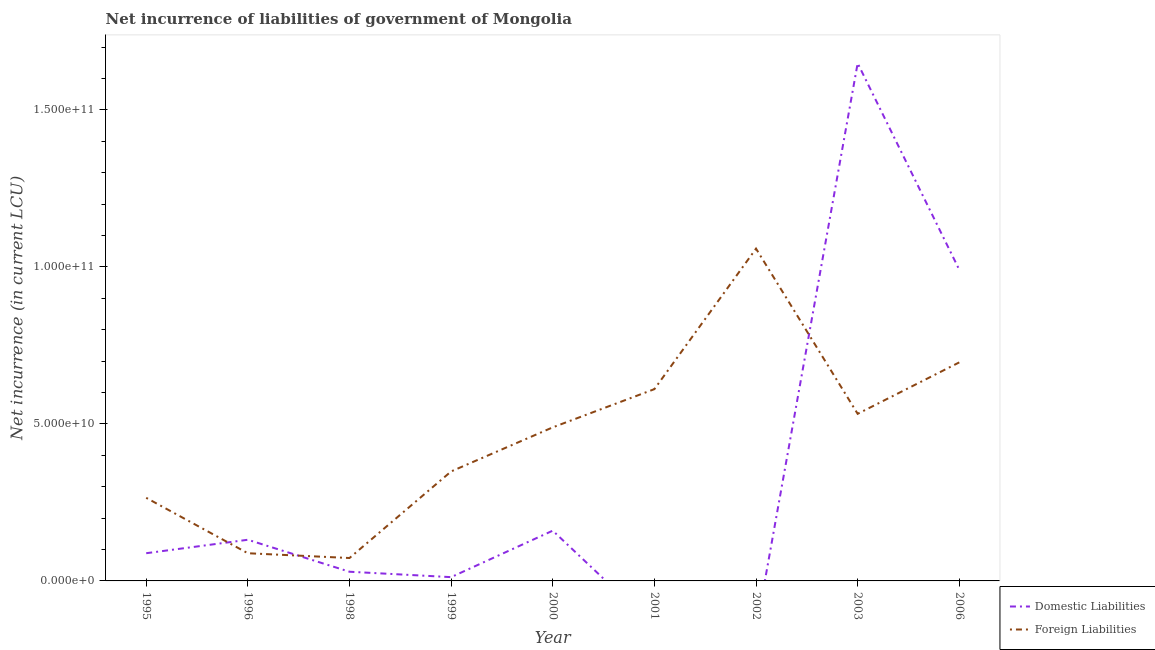How many different coloured lines are there?
Offer a very short reply. 2. Does the line corresponding to net incurrence of domestic liabilities intersect with the line corresponding to net incurrence of foreign liabilities?
Make the answer very short. Yes. What is the net incurrence of domestic liabilities in 2003?
Ensure brevity in your answer.  1.65e+11. Across all years, what is the maximum net incurrence of domestic liabilities?
Ensure brevity in your answer.  1.65e+11. Across all years, what is the minimum net incurrence of foreign liabilities?
Give a very brief answer. 7.29e+09. What is the total net incurrence of foreign liabilities in the graph?
Your answer should be very brief. 4.16e+11. What is the difference between the net incurrence of domestic liabilities in 1998 and that in 1999?
Make the answer very short. 1.72e+09. What is the difference between the net incurrence of foreign liabilities in 1996 and the net incurrence of domestic liabilities in 1998?
Your answer should be very brief. 5.89e+09. What is the average net incurrence of foreign liabilities per year?
Make the answer very short. 4.62e+1. In the year 2006, what is the difference between the net incurrence of foreign liabilities and net incurrence of domestic liabilities?
Your response must be concise. -2.95e+1. What is the ratio of the net incurrence of foreign liabilities in 2000 to that in 2002?
Your answer should be very brief. 0.46. Is the net incurrence of domestic liabilities in 1999 less than that in 2000?
Keep it short and to the point. Yes. What is the difference between the highest and the second highest net incurrence of foreign liabilities?
Make the answer very short. 3.62e+1. What is the difference between the highest and the lowest net incurrence of domestic liabilities?
Provide a succinct answer. 1.65e+11. Is the sum of the net incurrence of foreign liabilities in 2000 and 2002 greater than the maximum net incurrence of domestic liabilities across all years?
Make the answer very short. No. Does the net incurrence of domestic liabilities monotonically increase over the years?
Your response must be concise. No. Is the net incurrence of foreign liabilities strictly less than the net incurrence of domestic liabilities over the years?
Your response must be concise. No. How many lines are there?
Ensure brevity in your answer.  2. How many years are there in the graph?
Give a very brief answer. 9. Are the values on the major ticks of Y-axis written in scientific E-notation?
Provide a short and direct response. Yes. Does the graph contain grids?
Offer a terse response. No. How are the legend labels stacked?
Provide a succinct answer. Vertical. What is the title of the graph?
Keep it short and to the point. Net incurrence of liabilities of government of Mongolia. Does "Foreign Liabilities" appear as one of the legend labels in the graph?
Offer a terse response. Yes. What is the label or title of the Y-axis?
Keep it short and to the point. Net incurrence (in current LCU). What is the Net incurrence (in current LCU) in Domestic Liabilities in 1995?
Provide a short and direct response. 8.83e+09. What is the Net incurrence (in current LCU) of Foreign Liabilities in 1995?
Your answer should be very brief. 2.65e+1. What is the Net incurrence (in current LCU) in Domestic Liabilities in 1996?
Make the answer very short. 1.31e+1. What is the Net incurrence (in current LCU) of Foreign Liabilities in 1996?
Keep it short and to the point. 8.82e+09. What is the Net incurrence (in current LCU) of Domestic Liabilities in 1998?
Keep it short and to the point. 2.93e+09. What is the Net incurrence (in current LCU) of Foreign Liabilities in 1998?
Offer a terse response. 7.29e+09. What is the Net incurrence (in current LCU) in Domestic Liabilities in 1999?
Provide a short and direct response. 1.20e+09. What is the Net incurrence (in current LCU) in Foreign Liabilities in 1999?
Offer a terse response. 3.49e+1. What is the Net incurrence (in current LCU) of Domestic Liabilities in 2000?
Keep it short and to the point. 1.60e+1. What is the Net incurrence (in current LCU) of Foreign Liabilities in 2000?
Your answer should be very brief. 4.89e+1. What is the Net incurrence (in current LCU) in Domestic Liabilities in 2001?
Offer a very short reply. 0. What is the Net incurrence (in current LCU) in Foreign Liabilities in 2001?
Your response must be concise. 6.11e+1. What is the Net incurrence (in current LCU) of Domestic Liabilities in 2002?
Give a very brief answer. 0. What is the Net incurrence (in current LCU) in Foreign Liabilities in 2002?
Offer a very short reply. 1.06e+11. What is the Net incurrence (in current LCU) of Domestic Liabilities in 2003?
Make the answer very short. 1.65e+11. What is the Net incurrence (in current LCU) of Foreign Liabilities in 2003?
Give a very brief answer. 5.32e+1. What is the Net incurrence (in current LCU) of Domestic Liabilities in 2006?
Offer a terse response. 9.91e+1. What is the Net incurrence (in current LCU) in Foreign Liabilities in 2006?
Your answer should be very brief. 6.96e+1. Across all years, what is the maximum Net incurrence (in current LCU) of Domestic Liabilities?
Your answer should be very brief. 1.65e+11. Across all years, what is the maximum Net incurrence (in current LCU) of Foreign Liabilities?
Give a very brief answer. 1.06e+11. Across all years, what is the minimum Net incurrence (in current LCU) in Domestic Liabilities?
Make the answer very short. 0. Across all years, what is the minimum Net incurrence (in current LCU) of Foreign Liabilities?
Make the answer very short. 7.29e+09. What is the total Net incurrence (in current LCU) of Domestic Liabilities in the graph?
Offer a very short reply. 3.06e+11. What is the total Net incurrence (in current LCU) of Foreign Liabilities in the graph?
Ensure brevity in your answer.  4.16e+11. What is the difference between the Net incurrence (in current LCU) in Domestic Liabilities in 1995 and that in 1996?
Ensure brevity in your answer.  -4.28e+09. What is the difference between the Net incurrence (in current LCU) in Foreign Liabilities in 1995 and that in 1996?
Offer a very short reply. 1.77e+1. What is the difference between the Net incurrence (in current LCU) of Domestic Liabilities in 1995 and that in 1998?
Your answer should be very brief. 5.90e+09. What is the difference between the Net incurrence (in current LCU) in Foreign Liabilities in 1995 and that in 1998?
Offer a terse response. 1.92e+1. What is the difference between the Net incurrence (in current LCU) in Domestic Liabilities in 1995 and that in 1999?
Make the answer very short. 7.62e+09. What is the difference between the Net incurrence (in current LCU) of Foreign Liabilities in 1995 and that in 1999?
Offer a very short reply. -8.40e+09. What is the difference between the Net incurrence (in current LCU) of Domestic Liabilities in 1995 and that in 2000?
Offer a very short reply. -7.18e+09. What is the difference between the Net incurrence (in current LCU) in Foreign Liabilities in 1995 and that in 2000?
Provide a short and direct response. -2.24e+1. What is the difference between the Net incurrence (in current LCU) in Foreign Liabilities in 1995 and that in 2001?
Your answer should be very brief. -3.46e+1. What is the difference between the Net incurrence (in current LCU) in Foreign Liabilities in 1995 and that in 2002?
Give a very brief answer. -7.94e+1. What is the difference between the Net incurrence (in current LCU) in Domestic Liabilities in 1995 and that in 2003?
Make the answer very short. -1.56e+11. What is the difference between the Net incurrence (in current LCU) in Foreign Liabilities in 1995 and that in 2003?
Keep it short and to the point. -2.68e+1. What is the difference between the Net incurrence (in current LCU) of Domestic Liabilities in 1995 and that in 2006?
Provide a succinct answer. -9.03e+1. What is the difference between the Net incurrence (in current LCU) in Foreign Liabilities in 1995 and that in 2006?
Provide a succinct answer. -4.31e+1. What is the difference between the Net incurrence (in current LCU) of Domestic Liabilities in 1996 and that in 1998?
Give a very brief answer. 1.02e+1. What is the difference between the Net incurrence (in current LCU) in Foreign Liabilities in 1996 and that in 1998?
Offer a very short reply. 1.52e+09. What is the difference between the Net incurrence (in current LCU) of Domestic Liabilities in 1996 and that in 1999?
Ensure brevity in your answer.  1.19e+1. What is the difference between the Net incurrence (in current LCU) in Foreign Liabilities in 1996 and that in 1999?
Your response must be concise. -2.61e+1. What is the difference between the Net incurrence (in current LCU) of Domestic Liabilities in 1996 and that in 2000?
Keep it short and to the point. -2.90e+09. What is the difference between the Net incurrence (in current LCU) of Foreign Liabilities in 1996 and that in 2000?
Provide a short and direct response. -4.01e+1. What is the difference between the Net incurrence (in current LCU) of Foreign Liabilities in 1996 and that in 2001?
Keep it short and to the point. -5.23e+1. What is the difference between the Net incurrence (in current LCU) in Foreign Liabilities in 1996 and that in 2002?
Give a very brief answer. -9.70e+1. What is the difference between the Net incurrence (in current LCU) in Domestic Liabilities in 1996 and that in 2003?
Provide a succinct answer. -1.52e+11. What is the difference between the Net incurrence (in current LCU) in Foreign Liabilities in 1996 and that in 2003?
Your answer should be compact. -4.44e+1. What is the difference between the Net incurrence (in current LCU) of Domestic Liabilities in 1996 and that in 2006?
Give a very brief answer. -8.60e+1. What is the difference between the Net incurrence (in current LCU) in Foreign Liabilities in 1996 and that in 2006?
Keep it short and to the point. -6.08e+1. What is the difference between the Net incurrence (in current LCU) in Domestic Liabilities in 1998 and that in 1999?
Your response must be concise. 1.72e+09. What is the difference between the Net incurrence (in current LCU) of Foreign Liabilities in 1998 and that in 1999?
Ensure brevity in your answer.  -2.76e+1. What is the difference between the Net incurrence (in current LCU) of Domestic Liabilities in 1998 and that in 2000?
Provide a succinct answer. -1.31e+1. What is the difference between the Net incurrence (in current LCU) of Foreign Liabilities in 1998 and that in 2000?
Provide a short and direct response. -4.16e+1. What is the difference between the Net incurrence (in current LCU) of Foreign Liabilities in 1998 and that in 2001?
Your answer should be very brief. -5.38e+1. What is the difference between the Net incurrence (in current LCU) of Foreign Liabilities in 1998 and that in 2002?
Keep it short and to the point. -9.85e+1. What is the difference between the Net incurrence (in current LCU) in Domestic Liabilities in 1998 and that in 2003?
Provide a short and direct response. -1.62e+11. What is the difference between the Net incurrence (in current LCU) in Foreign Liabilities in 1998 and that in 2003?
Your answer should be compact. -4.59e+1. What is the difference between the Net incurrence (in current LCU) in Domestic Liabilities in 1998 and that in 2006?
Give a very brief answer. -9.62e+1. What is the difference between the Net incurrence (in current LCU) of Foreign Liabilities in 1998 and that in 2006?
Your answer should be very brief. -6.23e+1. What is the difference between the Net incurrence (in current LCU) of Domestic Liabilities in 1999 and that in 2000?
Provide a succinct answer. -1.48e+1. What is the difference between the Net incurrence (in current LCU) in Foreign Liabilities in 1999 and that in 2000?
Provide a succinct answer. -1.40e+1. What is the difference between the Net incurrence (in current LCU) of Foreign Liabilities in 1999 and that in 2001?
Make the answer very short. -2.62e+1. What is the difference between the Net incurrence (in current LCU) in Foreign Liabilities in 1999 and that in 2002?
Provide a succinct answer. -7.10e+1. What is the difference between the Net incurrence (in current LCU) of Domestic Liabilities in 1999 and that in 2003?
Your answer should be very brief. -1.64e+11. What is the difference between the Net incurrence (in current LCU) in Foreign Liabilities in 1999 and that in 2003?
Provide a succinct answer. -1.83e+1. What is the difference between the Net incurrence (in current LCU) of Domestic Liabilities in 1999 and that in 2006?
Give a very brief answer. -9.79e+1. What is the difference between the Net incurrence (in current LCU) in Foreign Liabilities in 1999 and that in 2006?
Your answer should be very brief. -3.47e+1. What is the difference between the Net incurrence (in current LCU) in Foreign Liabilities in 2000 and that in 2001?
Ensure brevity in your answer.  -1.22e+1. What is the difference between the Net incurrence (in current LCU) of Foreign Liabilities in 2000 and that in 2002?
Give a very brief answer. -5.69e+1. What is the difference between the Net incurrence (in current LCU) of Domestic Liabilities in 2000 and that in 2003?
Make the answer very short. -1.49e+11. What is the difference between the Net incurrence (in current LCU) of Foreign Liabilities in 2000 and that in 2003?
Offer a terse response. -4.31e+09. What is the difference between the Net incurrence (in current LCU) of Domestic Liabilities in 2000 and that in 2006?
Your answer should be very brief. -8.31e+1. What is the difference between the Net incurrence (in current LCU) in Foreign Liabilities in 2000 and that in 2006?
Offer a terse response. -2.07e+1. What is the difference between the Net incurrence (in current LCU) in Foreign Liabilities in 2001 and that in 2002?
Make the answer very short. -4.48e+1. What is the difference between the Net incurrence (in current LCU) in Foreign Liabilities in 2001 and that in 2003?
Offer a terse response. 7.86e+09. What is the difference between the Net incurrence (in current LCU) in Foreign Liabilities in 2001 and that in 2006?
Give a very brief answer. -8.53e+09. What is the difference between the Net incurrence (in current LCU) in Foreign Liabilities in 2002 and that in 2003?
Make the answer very short. 5.26e+1. What is the difference between the Net incurrence (in current LCU) in Foreign Liabilities in 2002 and that in 2006?
Your response must be concise. 3.62e+1. What is the difference between the Net incurrence (in current LCU) in Domestic Liabilities in 2003 and that in 2006?
Make the answer very short. 6.58e+1. What is the difference between the Net incurrence (in current LCU) in Foreign Liabilities in 2003 and that in 2006?
Ensure brevity in your answer.  -1.64e+1. What is the difference between the Net incurrence (in current LCU) of Domestic Liabilities in 1995 and the Net incurrence (in current LCU) of Foreign Liabilities in 1998?
Your response must be concise. 1.53e+09. What is the difference between the Net incurrence (in current LCU) in Domestic Liabilities in 1995 and the Net incurrence (in current LCU) in Foreign Liabilities in 1999?
Provide a short and direct response. -2.60e+1. What is the difference between the Net incurrence (in current LCU) of Domestic Liabilities in 1995 and the Net incurrence (in current LCU) of Foreign Liabilities in 2000?
Your answer should be very brief. -4.01e+1. What is the difference between the Net incurrence (in current LCU) of Domestic Liabilities in 1995 and the Net incurrence (in current LCU) of Foreign Liabilities in 2001?
Provide a short and direct response. -5.23e+1. What is the difference between the Net incurrence (in current LCU) of Domestic Liabilities in 1995 and the Net incurrence (in current LCU) of Foreign Liabilities in 2002?
Give a very brief answer. -9.70e+1. What is the difference between the Net incurrence (in current LCU) of Domestic Liabilities in 1995 and the Net incurrence (in current LCU) of Foreign Liabilities in 2003?
Keep it short and to the point. -4.44e+1. What is the difference between the Net incurrence (in current LCU) in Domestic Liabilities in 1995 and the Net incurrence (in current LCU) in Foreign Liabilities in 2006?
Offer a very short reply. -6.08e+1. What is the difference between the Net incurrence (in current LCU) of Domestic Liabilities in 1996 and the Net incurrence (in current LCU) of Foreign Liabilities in 1998?
Offer a very short reply. 5.82e+09. What is the difference between the Net incurrence (in current LCU) in Domestic Liabilities in 1996 and the Net incurrence (in current LCU) in Foreign Liabilities in 1999?
Your answer should be very brief. -2.18e+1. What is the difference between the Net incurrence (in current LCU) of Domestic Liabilities in 1996 and the Net incurrence (in current LCU) of Foreign Liabilities in 2000?
Your response must be concise. -3.58e+1. What is the difference between the Net incurrence (in current LCU) in Domestic Liabilities in 1996 and the Net incurrence (in current LCU) in Foreign Liabilities in 2001?
Offer a terse response. -4.80e+1. What is the difference between the Net incurrence (in current LCU) in Domestic Liabilities in 1996 and the Net incurrence (in current LCU) in Foreign Liabilities in 2002?
Your response must be concise. -9.27e+1. What is the difference between the Net incurrence (in current LCU) in Domestic Liabilities in 1996 and the Net incurrence (in current LCU) in Foreign Liabilities in 2003?
Your answer should be very brief. -4.01e+1. What is the difference between the Net incurrence (in current LCU) in Domestic Liabilities in 1996 and the Net incurrence (in current LCU) in Foreign Liabilities in 2006?
Provide a short and direct response. -5.65e+1. What is the difference between the Net incurrence (in current LCU) of Domestic Liabilities in 1998 and the Net incurrence (in current LCU) of Foreign Liabilities in 1999?
Offer a terse response. -3.19e+1. What is the difference between the Net incurrence (in current LCU) in Domestic Liabilities in 1998 and the Net incurrence (in current LCU) in Foreign Liabilities in 2000?
Your answer should be very brief. -4.60e+1. What is the difference between the Net incurrence (in current LCU) of Domestic Liabilities in 1998 and the Net incurrence (in current LCU) of Foreign Liabilities in 2001?
Ensure brevity in your answer.  -5.82e+1. What is the difference between the Net incurrence (in current LCU) of Domestic Liabilities in 1998 and the Net incurrence (in current LCU) of Foreign Liabilities in 2002?
Your response must be concise. -1.03e+11. What is the difference between the Net incurrence (in current LCU) of Domestic Liabilities in 1998 and the Net incurrence (in current LCU) of Foreign Liabilities in 2003?
Offer a terse response. -5.03e+1. What is the difference between the Net incurrence (in current LCU) of Domestic Liabilities in 1998 and the Net incurrence (in current LCU) of Foreign Liabilities in 2006?
Offer a very short reply. -6.67e+1. What is the difference between the Net incurrence (in current LCU) of Domestic Liabilities in 1999 and the Net incurrence (in current LCU) of Foreign Liabilities in 2000?
Your answer should be compact. -4.77e+1. What is the difference between the Net incurrence (in current LCU) of Domestic Liabilities in 1999 and the Net incurrence (in current LCU) of Foreign Liabilities in 2001?
Give a very brief answer. -5.99e+1. What is the difference between the Net incurrence (in current LCU) of Domestic Liabilities in 1999 and the Net incurrence (in current LCU) of Foreign Liabilities in 2002?
Your answer should be compact. -1.05e+11. What is the difference between the Net incurrence (in current LCU) in Domestic Liabilities in 1999 and the Net incurrence (in current LCU) in Foreign Liabilities in 2003?
Your answer should be compact. -5.20e+1. What is the difference between the Net incurrence (in current LCU) in Domestic Liabilities in 1999 and the Net incurrence (in current LCU) in Foreign Liabilities in 2006?
Ensure brevity in your answer.  -6.84e+1. What is the difference between the Net incurrence (in current LCU) in Domestic Liabilities in 2000 and the Net incurrence (in current LCU) in Foreign Liabilities in 2001?
Your response must be concise. -4.51e+1. What is the difference between the Net incurrence (in current LCU) of Domestic Liabilities in 2000 and the Net incurrence (in current LCU) of Foreign Liabilities in 2002?
Your answer should be very brief. -8.98e+1. What is the difference between the Net incurrence (in current LCU) of Domestic Liabilities in 2000 and the Net incurrence (in current LCU) of Foreign Liabilities in 2003?
Provide a short and direct response. -3.72e+1. What is the difference between the Net incurrence (in current LCU) in Domestic Liabilities in 2000 and the Net incurrence (in current LCU) in Foreign Liabilities in 2006?
Your answer should be compact. -5.36e+1. What is the difference between the Net incurrence (in current LCU) of Domestic Liabilities in 2003 and the Net incurrence (in current LCU) of Foreign Liabilities in 2006?
Offer a terse response. 9.53e+1. What is the average Net incurrence (in current LCU) in Domestic Liabilities per year?
Offer a very short reply. 3.40e+1. What is the average Net incurrence (in current LCU) of Foreign Liabilities per year?
Your answer should be very brief. 4.62e+1. In the year 1995, what is the difference between the Net incurrence (in current LCU) in Domestic Liabilities and Net incurrence (in current LCU) in Foreign Liabilities?
Provide a short and direct response. -1.76e+1. In the year 1996, what is the difference between the Net incurrence (in current LCU) in Domestic Liabilities and Net incurrence (in current LCU) in Foreign Liabilities?
Provide a short and direct response. 4.30e+09. In the year 1998, what is the difference between the Net incurrence (in current LCU) in Domestic Liabilities and Net incurrence (in current LCU) in Foreign Liabilities?
Keep it short and to the point. -4.37e+09. In the year 1999, what is the difference between the Net incurrence (in current LCU) of Domestic Liabilities and Net incurrence (in current LCU) of Foreign Liabilities?
Offer a terse response. -3.37e+1. In the year 2000, what is the difference between the Net incurrence (in current LCU) of Domestic Liabilities and Net incurrence (in current LCU) of Foreign Liabilities?
Your answer should be compact. -3.29e+1. In the year 2003, what is the difference between the Net incurrence (in current LCU) in Domestic Liabilities and Net incurrence (in current LCU) in Foreign Liabilities?
Your answer should be very brief. 1.12e+11. In the year 2006, what is the difference between the Net incurrence (in current LCU) in Domestic Liabilities and Net incurrence (in current LCU) in Foreign Liabilities?
Provide a short and direct response. 2.95e+1. What is the ratio of the Net incurrence (in current LCU) in Domestic Liabilities in 1995 to that in 1996?
Give a very brief answer. 0.67. What is the ratio of the Net incurrence (in current LCU) in Foreign Liabilities in 1995 to that in 1996?
Offer a terse response. 3. What is the ratio of the Net incurrence (in current LCU) in Domestic Liabilities in 1995 to that in 1998?
Offer a terse response. 3.02. What is the ratio of the Net incurrence (in current LCU) in Foreign Liabilities in 1995 to that in 1998?
Offer a very short reply. 3.63. What is the ratio of the Net incurrence (in current LCU) in Domestic Liabilities in 1995 to that in 1999?
Keep it short and to the point. 7.33. What is the ratio of the Net incurrence (in current LCU) in Foreign Liabilities in 1995 to that in 1999?
Your response must be concise. 0.76. What is the ratio of the Net incurrence (in current LCU) of Domestic Liabilities in 1995 to that in 2000?
Your response must be concise. 0.55. What is the ratio of the Net incurrence (in current LCU) in Foreign Liabilities in 1995 to that in 2000?
Provide a succinct answer. 0.54. What is the ratio of the Net incurrence (in current LCU) of Foreign Liabilities in 1995 to that in 2001?
Make the answer very short. 0.43. What is the ratio of the Net incurrence (in current LCU) in Foreign Liabilities in 1995 to that in 2002?
Ensure brevity in your answer.  0.25. What is the ratio of the Net incurrence (in current LCU) of Domestic Liabilities in 1995 to that in 2003?
Ensure brevity in your answer.  0.05. What is the ratio of the Net incurrence (in current LCU) of Foreign Liabilities in 1995 to that in 2003?
Your response must be concise. 0.5. What is the ratio of the Net incurrence (in current LCU) of Domestic Liabilities in 1995 to that in 2006?
Provide a short and direct response. 0.09. What is the ratio of the Net incurrence (in current LCU) of Foreign Liabilities in 1995 to that in 2006?
Your answer should be very brief. 0.38. What is the ratio of the Net incurrence (in current LCU) in Domestic Liabilities in 1996 to that in 1998?
Give a very brief answer. 4.48. What is the ratio of the Net incurrence (in current LCU) in Foreign Liabilities in 1996 to that in 1998?
Make the answer very short. 1.21. What is the ratio of the Net incurrence (in current LCU) of Domestic Liabilities in 1996 to that in 1999?
Keep it short and to the point. 10.89. What is the ratio of the Net incurrence (in current LCU) in Foreign Liabilities in 1996 to that in 1999?
Offer a terse response. 0.25. What is the ratio of the Net incurrence (in current LCU) in Domestic Liabilities in 1996 to that in 2000?
Ensure brevity in your answer.  0.82. What is the ratio of the Net incurrence (in current LCU) of Foreign Liabilities in 1996 to that in 2000?
Make the answer very short. 0.18. What is the ratio of the Net incurrence (in current LCU) in Foreign Liabilities in 1996 to that in 2001?
Your answer should be very brief. 0.14. What is the ratio of the Net incurrence (in current LCU) of Foreign Liabilities in 1996 to that in 2002?
Your response must be concise. 0.08. What is the ratio of the Net incurrence (in current LCU) in Domestic Liabilities in 1996 to that in 2003?
Offer a terse response. 0.08. What is the ratio of the Net incurrence (in current LCU) in Foreign Liabilities in 1996 to that in 2003?
Your response must be concise. 0.17. What is the ratio of the Net incurrence (in current LCU) of Domestic Liabilities in 1996 to that in 2006?
Provide a succinct answer. 0.13. What is the ratio of the Net incurrence (in current LCU) in Foreign Liabilities in 1996 to that in 2006?
Make the answer very short. 0.13. What is the ratio of the Net incurrence (in current LCU) of Domestic Liabilities in 1998 to that in 1999?
Offer a very short reply. 2.43. What is the ratio of the Net incurrence (in current LCU) in Foreign Liabilities in 1998 to that in 1999?
Make the answer very short. 0.21. What is the ratio of the Net incurrence (in current LCU) of Domestic Liabilities in 1998 to that in 2000?
Provide a succinct answer. 0.18. What is the ratio of the Net incurrence (in current LCU) of Foreign Liabilities in 1998 to that in 2000?
Provide a short and direct response. 0.15. What is the ratio of the Net incurrence (in current LCU) in Foreign Liabilities in 1998 to that in 2001?
Offer a terse response. 0.12. What is the ratio of the Net incurrence (in current LCU) of Foreign Liabilities in 1998 to that in 2002?
Give a very brief answer. 0.07. What is the ratio of the Net incurrence (in current LCU) of Domestic Liabilities in 1998 to that in 2003?
Provide a succinct answer. 0.02. What is the ratio of the Net incurrence (in current LCU) of Foreign Liabilities in 1998 to that in 2003?
Your response must be concise. 0.14. What is the ratio of the Net incurrence (in current LCU) of Domestic Liabilities in 1998 to that in 2006?
Your answer should be very brief. 0.03. What is the ratio of the Net incurrence (in current LCU) of Foreign Liabilities in 1998 to that in 2006?
Your response must be concise. 0.1. What is the ratio of the Net incurrence (in current LCU) of Domestic Liabilities in 1999 to that in 2000?
Provide a succinct answer. 0.08. What is the ratio of the Net incurrence (in current LCU) in Foreign Liabilities in 1999 to that in 2000?
Your response must be concise. 0.71. What is the ratio of the Net incurrence (in current LCU) in Foreign Liabilities in 1999 to that in 2001?
Provide a succinct answer. 0.57. What is the ratio of the Net incurrence (in current LCU) of Foreign Liabilities in 1999 to that in 2002?
Your answer should be compact. 0.33. What is the ratio of the Net incurrence (in current LCU) in Domestic Liabilities in 1999 to that in 2003?
Your response must be concise. 0.01. What is the ratio of the Net incurrence (in current LCU) in Foreign Liabilities in 1999 to that in 2003?
Keep it short and to the point. 0.66. What is the ratio of the Net incurrence (in current LCU) in Domestic Liabilities in 1999 to that in 2006?
Offer a terse response. 0.01. What is the ratio of the Net incurrence (in current LCU) of Foreign Liabilities in 1999 to that in 2006?
Give a very brief answer. 0.5. What is the ratio of the Net incurrence (in current LCU) in Foreign Liabilities in 2000 to that in 2001?
Ensure brevity in your answer.  0.8. What is the ratio of the Net incurrence (in current LCU) of Foreign Liabilities in 2000 to that in 2002?
Your response must be concise. 0.46. What is the ratio of the Net incurrence (in current LCU) in Domestic Liabilities in 2000 to that in 2003?
Your answer should be compact. 0.1. What is the ratio of the Net incurrence (in current LCU) of Foreign Liabilities in 2000 to that in 2003?
Your response must be concise. 0.92. What is the ratio of the Net incurrence (in current LCU) in Domestic Liabilities in 2000 to that in 2006?
Provide a succinct answer. 0.16. What is the ratio of the Net incurrence (in current LCU) of Foreign Liabilities in 2000 to that in 2006?
Give a very brief answer. 0.7. What is the ratio of the Net incurrence (in current LCU) in Foreign Liabilities in 2001 to that in 2002?
Provide a succinct answer. 0.58. What is the ratio of the Net incurrence (in current LCU) of Foreign Liabilities in 2001 to that in 2003?
Offer a very short reply. 1.15. What is the ratio of the Net incurrence (in current LCU) of Foreign Liabilities in 2001 to that in 2006?
Give a very brief answer. 0.88. What is the ratio of the Net incurrence (in current LCU) in Foreign Liabilities in 2002 to that in 2003?
Keep it short and to the point. 1.99. What is the ratio of the Net incurrence (in current LCU) of Foreign Liabilities in 2002 to that in 2006?
Provide a succinct answer. 1.52. What is the ratio of the Net incurrence (in current LCU) in Domestic Liabilities in 2003 to that in 2006?
Your answer should be very brief. 1.66. What is the ratio of the Net incurrence (in current LCU) of Foreign Liabilities in 2003 to that in 2006?
Keep it short and to the point. 0.76. What is the difference between the highest and the second highest Net incurrence (in current LCU) of Domestic Liabilities?
Your response must be concise. 6.58e+1. What is the difference between the highest and the second highest Net incurrence (in current LCU) in Foreign Liabilities?
Your answer should be compact. 3.62e+1. What is the difference between the highest and the lowest Net incurrence (in current LCU) of Domestic Liabilities?
Provide a short and direct response. 1.65e+11. What is the difference between the highest and the lowest Net incurrence (in current LCU) in Foreign Liabilities?
Your answer should be compact. 9.85e+1. 